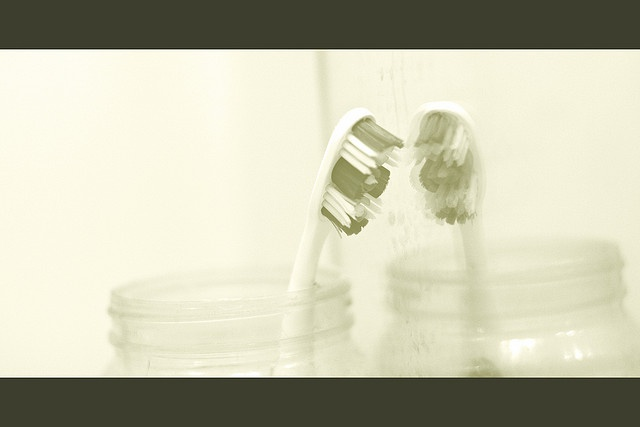Describe the objects in this image and their specific colors. I can see toothbrush in black, beige, and tan tones and toothbrush in black, beige, olive, and tan tones in this image. 